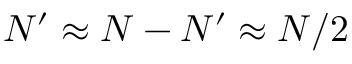<formula> <loc_0><loc_0><loc_500><loc_500>N ^ { \prime } \approx N - N ^ { \prime } \approx N / 2</formula> 